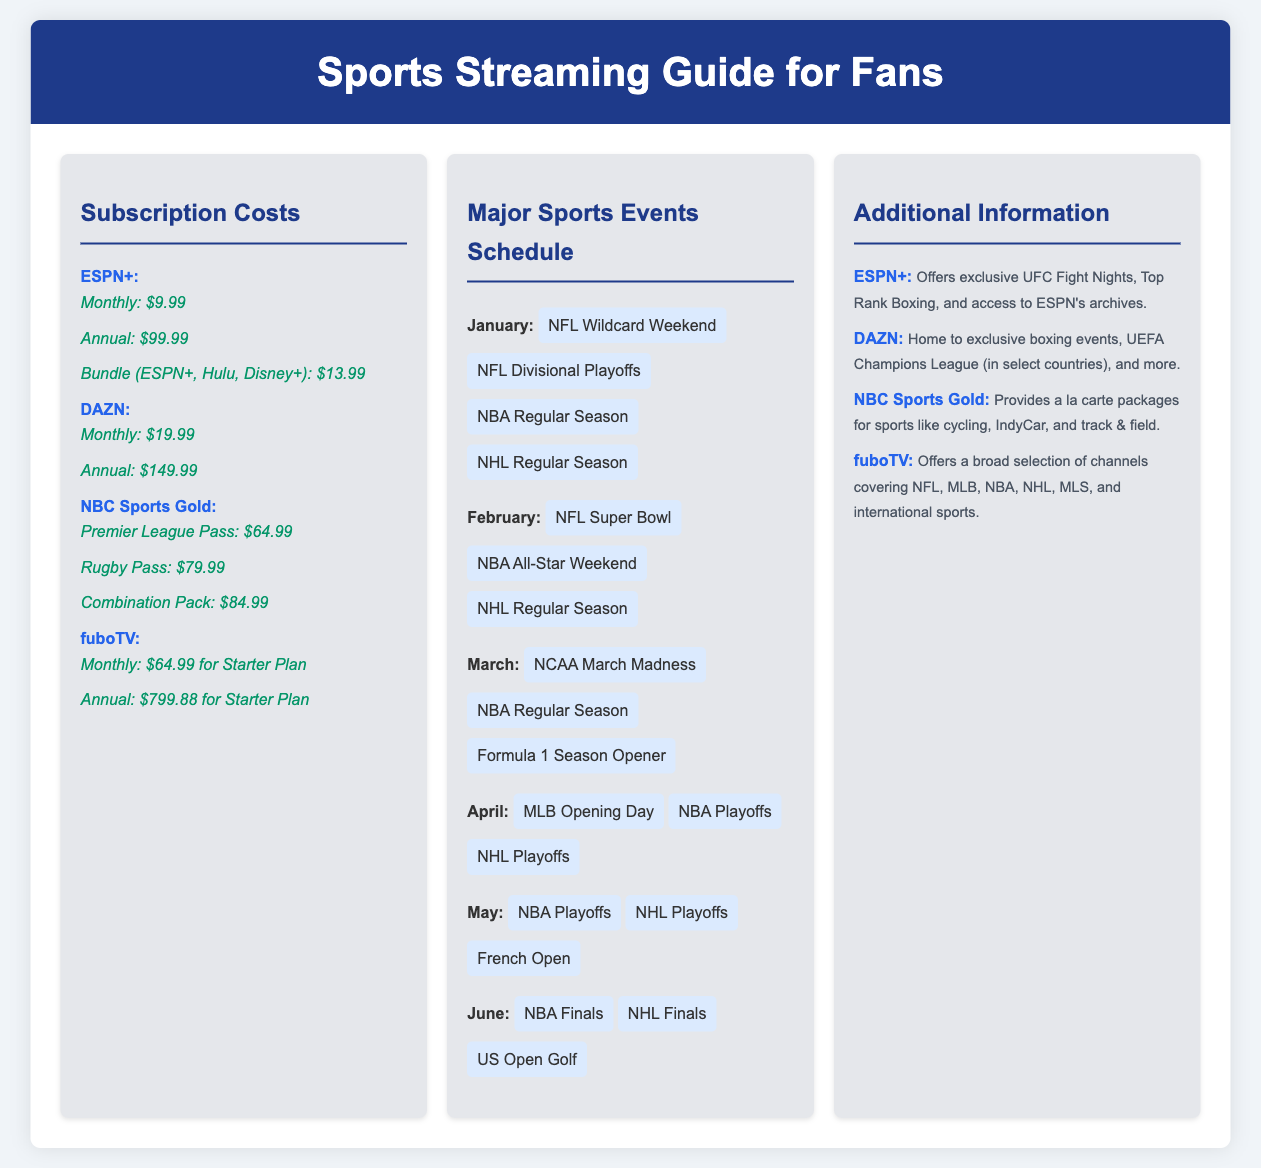What is the monthly subscription cost for ESPN+? The monthly subscription cost for ESPN+ is listed in the document as $9.99.
Answer: $9.99 What event takes place in February? February features the NFL Super Bowl and NBA All-Star Weekend as scheduled events.
Answer: NFL Super Bowl What is the annual cost of DAZN? The document specifies the annual cost of DAZN subscription.
Answer: $149.99 Which platform offers a combination pack for rugby and Premier League? The platform that offers a Combination Pack is NBC Sports Gold, according to the document details.
Answer: NBC Sports Gold How many major sports events are listed for June? The document mentions three major sports events happening in June.
Answer: 3 What is the total monthly fee of the bundle for ESPN+, Hulu, and Disney+? The document lists the bundle of ESPN+, Hulu, and Disney+ at $13.99 as its total monthly fee.
Answer: $13.99 Which service offers a broad selection of channels for international sports? The document specifically notes that fuboTV offers a broad selection of channels covering international sports.
Answer: fuboTV What major sports event starts the month of March? The NCAA March Madness is the highlighted major sports event occurring in March according to the schedule.
Answer: NCAA March Madness What is the price of the Premier League Pass on NBC Sports Gold? The document indicates that the price of the Premier League Pass is $64.99.
Answer: $64.99 